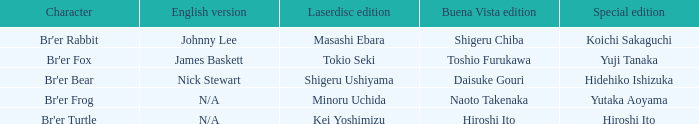What is the english version that is buena vista edition is daisuke gouri? Nick Stewart. 